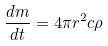<formula> <loc_0><loc_0><loc_500><loc_500>\frac { d m } { d t } = 4 \pi r ^ { 2 } c \rho</formula> 